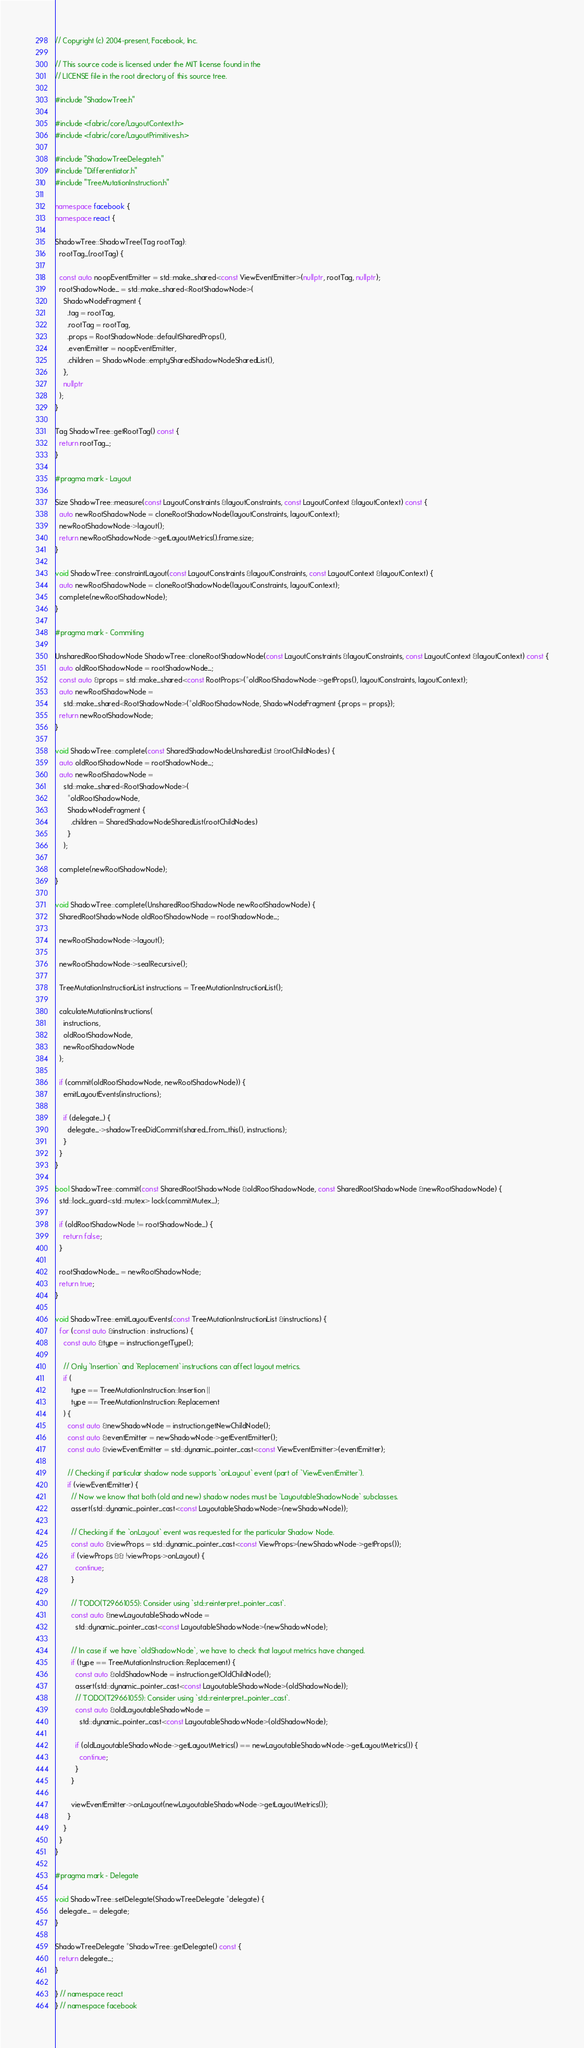<code> <loc_0><loc_0><loc_500><loc_500><_C++_>// Copyright (c) 2004-present, Facebook, Inc.

// This source code is licensed under the MIT license found in the
// LICENSE file in the root directory of this source tree.

#include "ShadowTree.h"

#include <fabric/core/LayoutContext.h>
#include <fabric/core/LayoutPrimitives.h>

#include "ShadowTreeDelegate.h"
#include "Differentiator.h"
#include "TreeMutationInstruction.h"

namespace facebook {
namespace react {

ShadowTree::ShadowTree(Tag rootTag):
  rootTag_(rootTag) {

  const auto noopEventEmitter = std::make_shared<const ViewEventEmitter>(nullptr, rootTag, nullptr);
  rootShadowNode_ = std::make_shared<RootShadowNode>(
    ShadowNodeFragment {
      .tag = rootTag,
      .rootTag = rootTag,
      .props = RootShadowNode::defaultSharedProps(),
      .eventEmitter = noopEventEmitter,
      .children = ShadowNode::emptySharedShadowNodeSharedList(),
    },
    nullptr
  );
}

Tag ShadowTree::getRootTag() const {
  return rootTag_;
}

#pragma mark - Layout

Size ShadowTree::measure(const LayoutConstraints &layoutConstraints, const LayoutContext &layoutContext) const {
  auto newRootShadowNode = cloneRootShadowNode(layoutConstraints, layoutContext);
  newRootShadowNode->layout();
  return newRootShadowNode->getLayoutMetrics().frame.size;
}

void ShadowTree::constraintLayout(const LayoutConstraints &layoutConstraints, const LayoutContext &layoutContext) {
  auto newRootShadowNode = cloneRootShadowNode(layoutConstraints, layoutContext);
  complete(newRootShadowNode);
}

#pragma mark - Commiting

UnsharedRootShadowNode ShadowTree::cloneRootShadowNode(const LayoutConstraints &layoutConstraints, const LayoutContext &layoutContext) const {
  auto oldRootShadowNode = rootShadowNode_;
  const auto &props = std::make_shared<const RootProps>(*oldRootShadowNode->getProps(), layoutConstraints, layoutContext);
  auto newRootShadowNode =
    std::make_shared<RootShadowNode>(*oldRootShadowNode, ShadowNodeFragment {.props = props});
  return newRootShadowNode;
}

void ShadowTree::complete(const SharedShadowNodeUnsharedList &rootChildNodes) {
  auto oldRootShadowNode = rootShadowNode_;
  auto newRootShadowNode =
    std::make_shared<RootShadowNode>(
      *oldRootShadowNode,
      ShadowNodeFragment {
        .children = SharedShadowNodeSharedList(rootChildNodes)
      }
    );

  complete(newRootShadowNode);
}

void ShadowTree::complete(UnsharedRootShadowNode newRootShadowNode) {
  SharedRootShadowNode oldRootShadowNode = rootShadowNode_;

  newRootShadowNode->layout();

  newRootShadowNode->sealRecursive();

  TreeMutationInstructionList instructions = TreeMutationInstructionList();

  calculateMutationInstructions(
    instructions,
    oldRootShadowNode,
    newRootShadowNode
  );

  if (commit(oldRootShadowNode, newRootShadowNode)) {
    emitLayoutEvents(instructions);

    if (delegate_) {
      delegate_->shadowTreeDidCommit(shared_from_this(), instructions);
    }
  }
}

bool ShadowTree::commit(const SharedRootShadowNode &oldRootShadowNode, const SharedRootShadowNode &newRootShadowNode) {
  std::lock_guard<std::mutex> lock(commitMutex_);

  if (oldRootShadowNode != rootShadowNode_) {
    return false;
  }

  rootShadowNode_ = newRootShadowNode;
  return true;
}

void ShadowTree::emitLayoutEvents(const TreeMutationInstructionList &instructions) {
  for (const auto &instruction : instructions) {
    const auto &type = instruction.getType();

    // Only `Insertion` and `Replacement` instructions can affect layout metrics.
    if (
        type == TreeMutationInstruction::Insertion ||
        type == TreeMutationInstruction::Replacement
    ) {
      const auto &newShadowNode = instruction.getNewChildNode();
      const auto &eventEmitter = newShadowNode->getEventEmitter();
      const auto &viewEventEmitter = std::dynamic_pointer_cast<const ViewEventEmitter>(eventEmitter);

      // Checking if particular shadow node supports `onLayout` event (part of `ViewEventEmitter`).
      if (viewEventEmitter) {
        // Now we know that both (old and new) shadow nodes must be `LayoutableShadowNode` subclasses.
        assert(std::dynamic_pointer_cast<const LayoutableShadowNode>(newShadowNode));

        // Checking if the `onLayout` event was requested for the particular Shadow Node.
        const auto &viewProps = std::dynamic_pointer_cast<const ViewProps>(newShadowNode->getProps());
        if (viewProps && !viewProps->onLayout) {
          continue;
        }

        // TODO(T29661055): Consider using `std::reinterpret_pointer_cast`.
        const auto &newLayoutableShadowNode =
          std::dynamic_pointer_cast<const LayoutableShadowNode>(newShadowNode);

        // In case if we have `oldShadowNode`, we have to check that layout metrics have changed.
        if (type == TreeMutationInstruction::Replacement) {
          const auto &oldShadowNode = instruction.getOldChildNode();
          assert(std::dynamic_pointer_cast<const LayoutableShadowNode>(oldShadowNode));
          // TODO(T29661055): Consider using `std::reinterpret_pointer_cast`.
          const auto &oldLayoutableShadowNode =
            std::dynamic_pointer_cast<const LayoutableShadowNode>(oldShadowNode);

          if (oldLayoutableShadowNode->getLayoutMetrics() == newLayoutableShadowNode->getLayoutMetrics()) {
            continue;
          }
        }

        viewEventEmitter->onLayout(newLayoutableShadowNode->getLayoutMetrics());
      }
    }
  }
}

#pragma mark - Delegate

void ShadowTree::setDelegate(ShadowTreeDelegate *delegate) {
  delegate_ = delegate;
}

ShadowTreeDelegate *ShadowTree::getDelegate() const {
  return delegate_;
}

} // namespace react
} // namespace facebook
</code> 